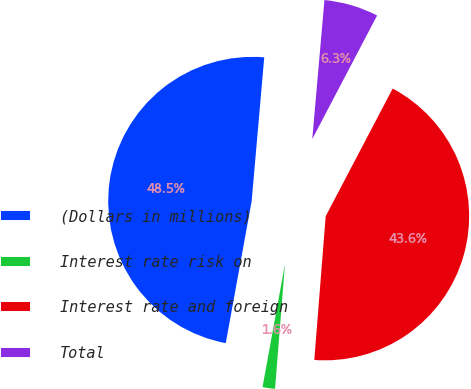Convert chart to OTSL. <chart><loc_0><loc_0><loc_500><loc_500><pie_chart><fcel>(Dollars in millions)<fcel>Interest rate risk on<fcel>Interest rate and foreign<fcel>Total<nl><fcel>48.52%<fcel>1.61%<fcel>43.57%<fcel>6.3%<nl></chart> 